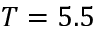Convert formula to latex. <formula><loc_0><loc_0><loc_500><loc_500>T = 5 . 5</formula> 